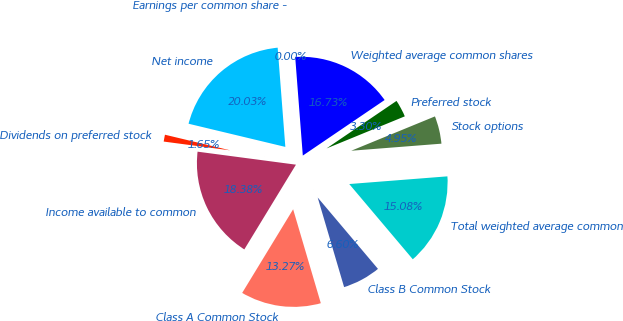<chart> <loc_0><loc_0><loc_500><loc_500><pie_chart><fcel>Net income<fcel>Dividends on preferred stock<fcel>Income available to common<fcel>Class A Common Stock<fcel>Class B Common Stock<fcel>Total weighted average common<fcel>Stock options<fcel>Preferred stock<fcel>Weighted average common shares<fcel>Earnings per common share -<nl><fcel>20.03%<fcel>1.65%<fcel>18.38%<fcel>13.27%<fcel>6.6%<fcel>15.08%<fcel>4.95%<fcel>3.3%<fcel>16.73%<fcel>0.0%<nl></chart> 